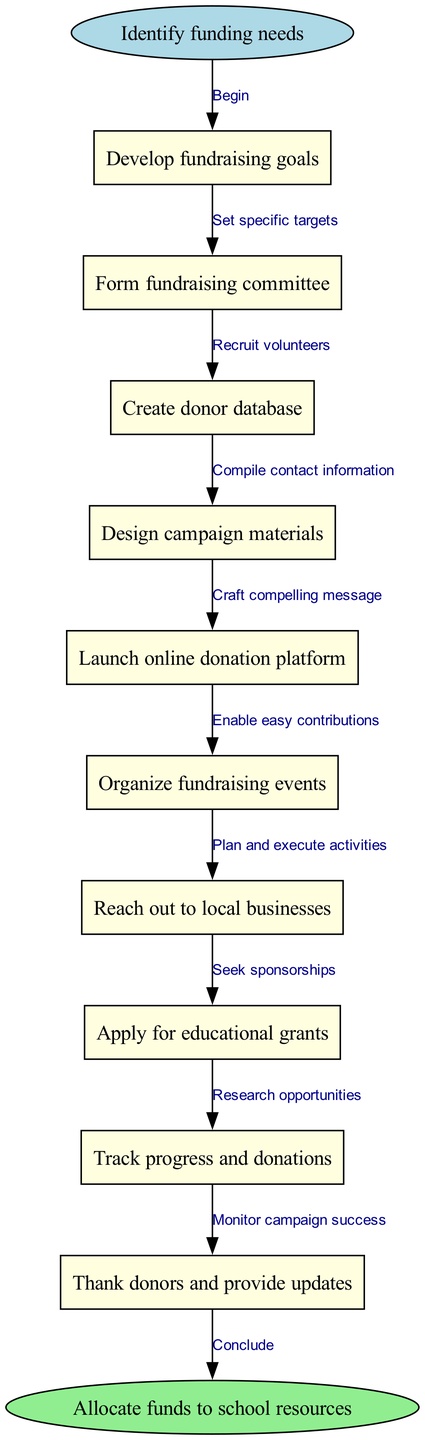What is the starting point of the diagram? The starting point, indicated as a node in the diagram, is "Identify funding needs." It is the first action or step necessary to initiate the fundraising campaign strategy.
Answer: Identify funding needs How many main nodes are there in the diagram? The total number of main nodes is counted from the list of nodes, which includes ten entries. This is done by simply tallying all the nodes listed under the "nodes" key in the provided data.
Answer: 10 What is the final step outlined in the diagram? The final step, shown in the end node, is "Allocate funds to school resources." This is where all prior activities lead to the ultimate goal of distributing the acquired funds.
Answer: Allocate funds to school resources Which fundraising strategy comes directly after forming the fundraising committee? After the node "Form fundraising committee," the next node is "Create donor database." This shows the progression from gathering people to essential preparatory work for fundraising efforts.
Answer: Create donor database What type of relationship connects "Reach out to local businesses" and "Organize fundraising events"? The edge that connects these two nodes is categorized as a sequential relationship, as "Reach out to local businesses" is a prior step that facilitates the subsequent action of "Organize fundraising events."
Answer: Sequential relationship What is the total number of edges in the diagram? The number of edges is derived by recognizing that each transition between nodes represents a directed edge. Based on the connections listed, there are nine edges in total which correspond to the number of relationships between the ten nodes.
Answer: 9 What is the primary action taken after "Track progress and donations"? The action that directly follows "Track progress and donations" is "Thank donors and provide updates," reflecting a necessary step in maintaining donor relationships after collecting funds.
Answer: Thank donors and provide updates How does "Apply for educational grants" relate to the overall fundraising strategy? "Apply for educational grants" is one of the primary actions in achieving fundraising goals, indicating an alternative funding source that aligns with the overall strategy in the diagram to secure additional resources for the school.
Answer: Alternative funding source What node precedes "Launch online donation platform"? The node that comes just before "Launch online donation platform" is "Design campaign materials." This shows that preparing materials is necessary before implementing the online platform for contributions.
Answer: Design campaign materials 